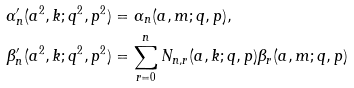Convert formula to latex. <formula><loc_0><loc_0><loc_500><loc_500>\alpha ^ { \prime } _ { n } ( a ^ { 2 } , k ; q ^ { 2 } , p ^ { 2 } ) & = \alpha _ { n } ( a , m ; q , p ) , \\ \beta ^ { \prime } _ { n } ( a ^ { 2 } , k ; q ^ { 2 } , p ^ { 2 } ) & = \sum _ { r = 0 } ^ { n } N _ { n , r } ( a , k ; q , p ) \beta _ { r } ( a , m ; q , p )</formula> 